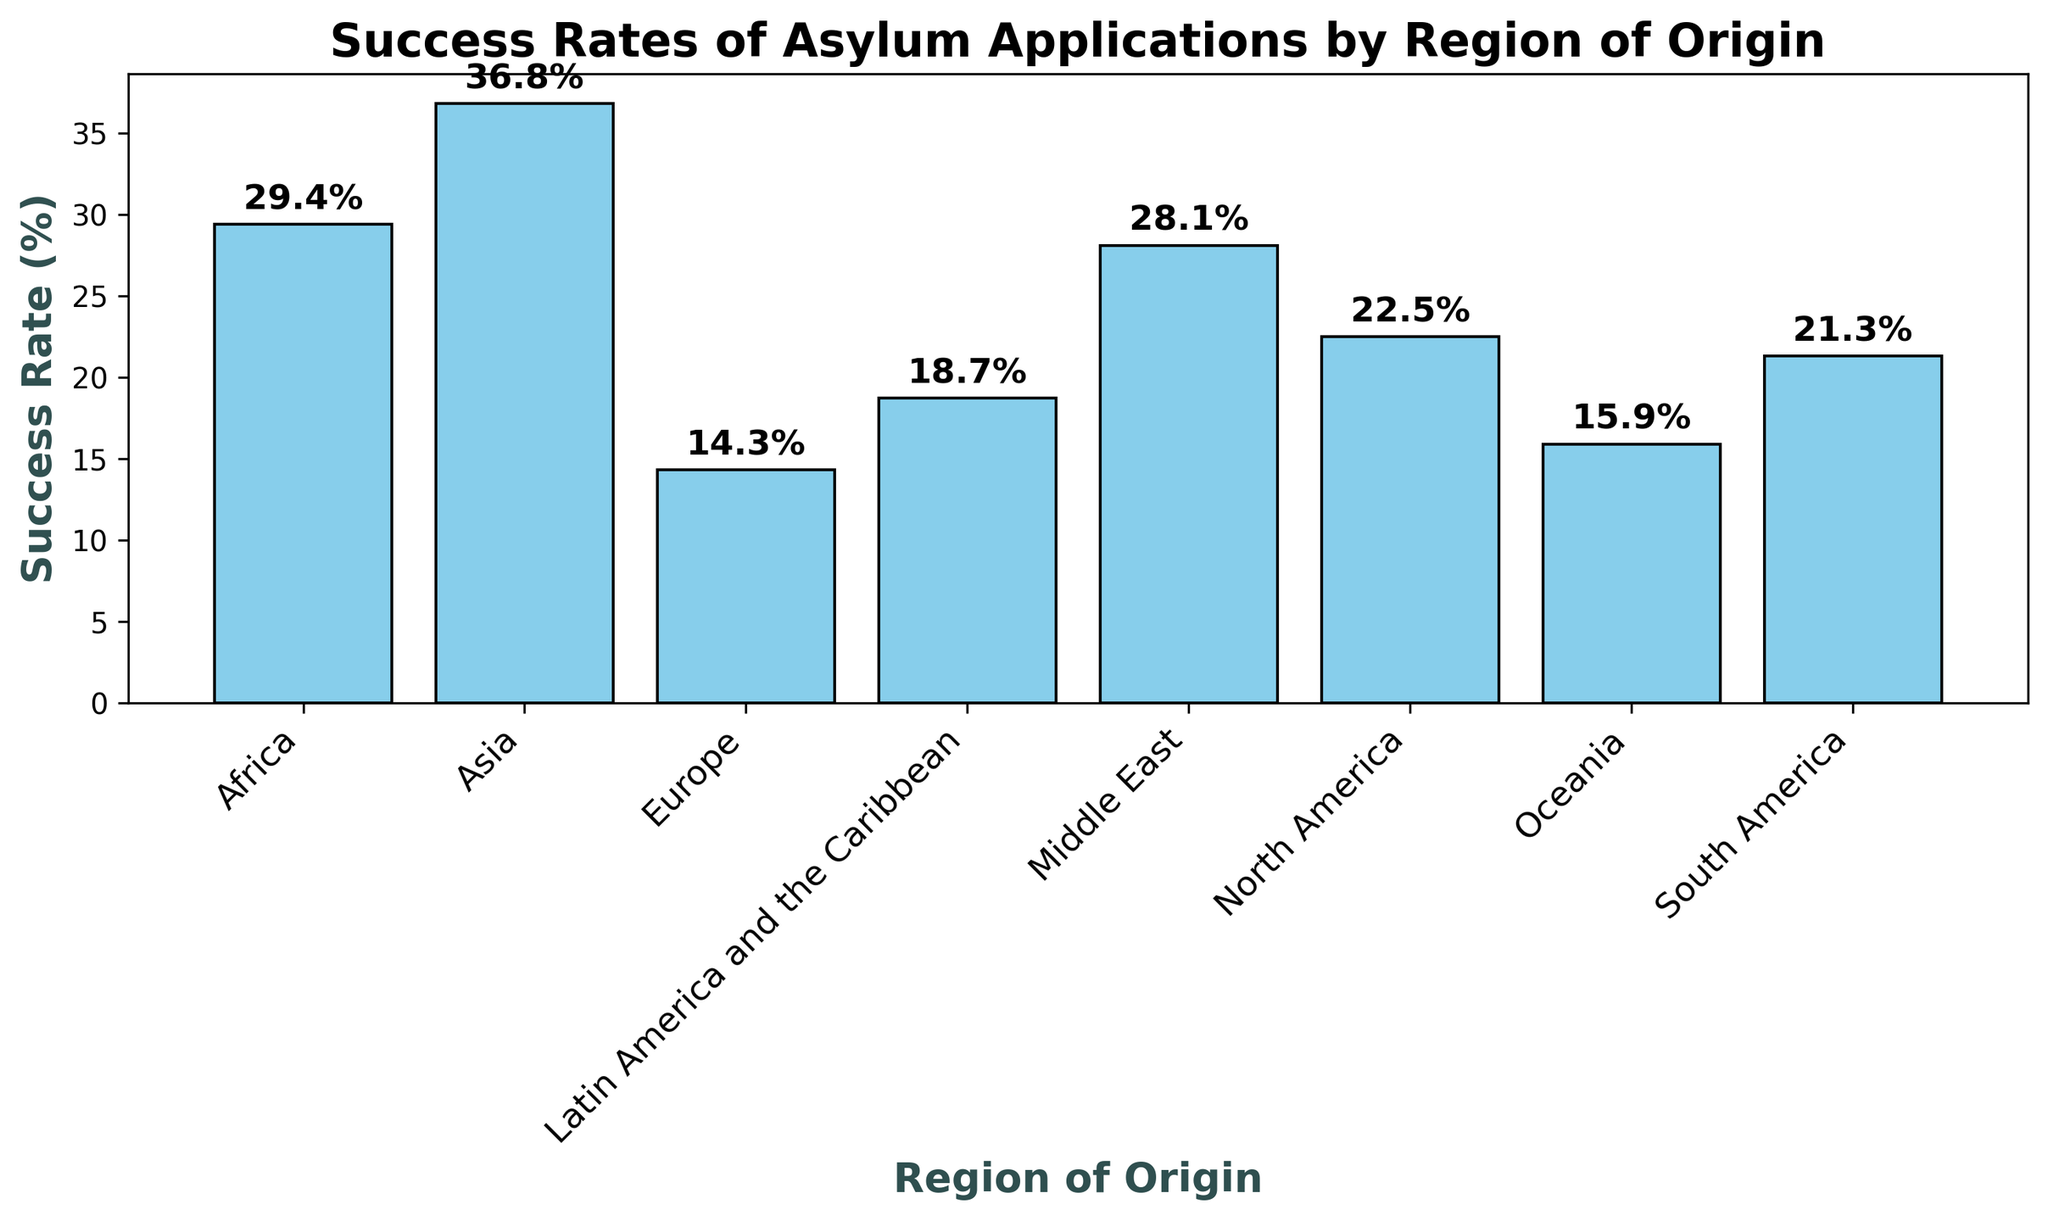What region has the highest success rate of asylum applications? The bar chart shows the success rates of asylum applications by region of origin. By comparing the heights of the bars, Asia has the highest success rate with 36.8%.
Answer: Asia What region has the lowest success rate of asylum applications? By looking at the bar chart, Europe has the lowest success rate of asylum applications, which is 14.3%.
Answer: Europe How does the success rate of South America compare to North America? By examining the bar chart, South America's success rate is 21.3% while North America's success rate is 22.5%. Therefore, North America's success rate is slightly higher.
Answer: North America has a slightly higher success rate than South America What is the average success rate across all regions? To find the average success rate, sum all the success rates and divide by the number of regions. The sum is 29.4 + 36.8 + 14.3 + 18.7 + 28.1 + 22.5 + 15.9 + 21.3 = 187.  Dividing by 8 regions: 187/8 = 23.375%.
Answer: 23.375% What is the difference in success rate between Asia and Europe? Subtract Europe's success rate from Asia's success rate: 36.8% - 14.3% = 22.5%.
Answer: 22.5% What is the median success rate of asylum applications across all regions? To find the median, list the success rates in ascending order: 14.3%, 15.9%, 18.7%, 21.3%, 22.5%, 28.1%, 29.4%, 36.8%. The middle values are 21.3% and 22.5%. The median is the average of these two values: (21.3 + 22.5) / 2 = 21.9%.
Answer: 21.9% Which regions have a success rate greater than 25%? By looking at the bar chart, the regions with success rates greater than 25% are Africa (29.4%), Asia (36.8%), and Middle East (28.1%).
Answer: Africa, Asia, Middle East How much higher is Asia's success rate compared to Latin America and the Caribbean? Subtract Latin America's success rate from Asia's success rate: 36.8% - 18.7% = 18.1%.
Answer: 18.1% What is the combined success rate of Africa and the Middle East? To find the combined success rate, add the rates of Africa and the Middle East: 29.4% + 28.1% = 57.5%.
Answer: 57.5% What is noticeable about the bar for Asia? The bar for Asia is noticeably taller than the other bars, indicating it has the highest success rate of 36.8%.
Answer: The highest success rate 